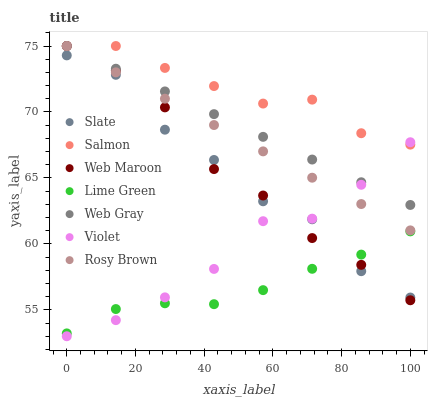Does Lime Green have the minimum area under the curve?
Answer yes or no. Yes. Does Salmon have the maximum area under the curve?
Answer yes or no. Yes. Does Slate have the minimum area under the curve?
Answer yes or no. No. Does Slate have the maximum area under the curve?
Answer yes or no. No. Is Rosy Brown the smoothest?
Answer yes or no. Yes. Is Slate the roughest?
Answer yes or no. Yes. Is Salmon the smoothest?
Answer yes or no. No. Is Salmon the roughest?
Answer yes or no. No. Does Violet have the lowest value?
Answer yes or no. Yes. Does Slate have the lowest value?
Answer yes or no. No. Does Web Maroon have the highest value?
Answer yes or no. Yes. Does Slate have the highest value?
Answer yes or no. No. Is Slate less than Rosy Brown?
Answer yes or no. Yes. Is Rosy Brown greater than Lime Green?
Answer yes or no. Yes. Does Lime Green intersect Web Maroon?
Answer yes or no. Yes. Is Lime Green less than Web Maroon?
Answer yes or no. No. Is Lime Green greater than Web Maroon?
Answer yes or no. No. Does Slate intersect Rosy Brown?
Answer yes or no. No. 